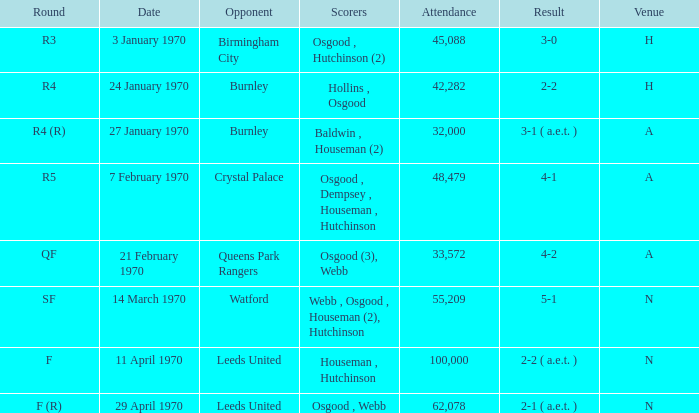What is the highest attendance at a game with a result of 5-1? 55209.0. 